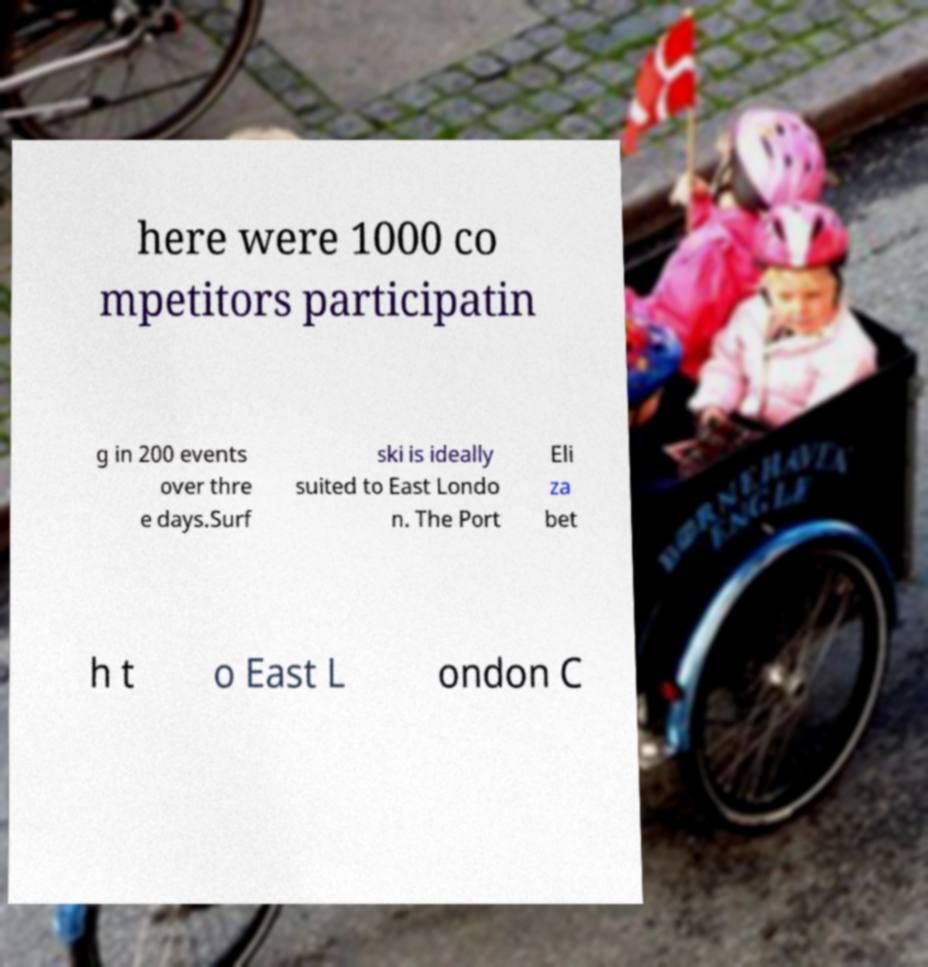What messages or text are displayed in this image? I need them in a readable, typed format. here were 1000 co mpetitors participatin g in 200 events over thre e days.Surf ski is ideally suited to East Londo n. The Port Eli za bet h t o East L ondon C 